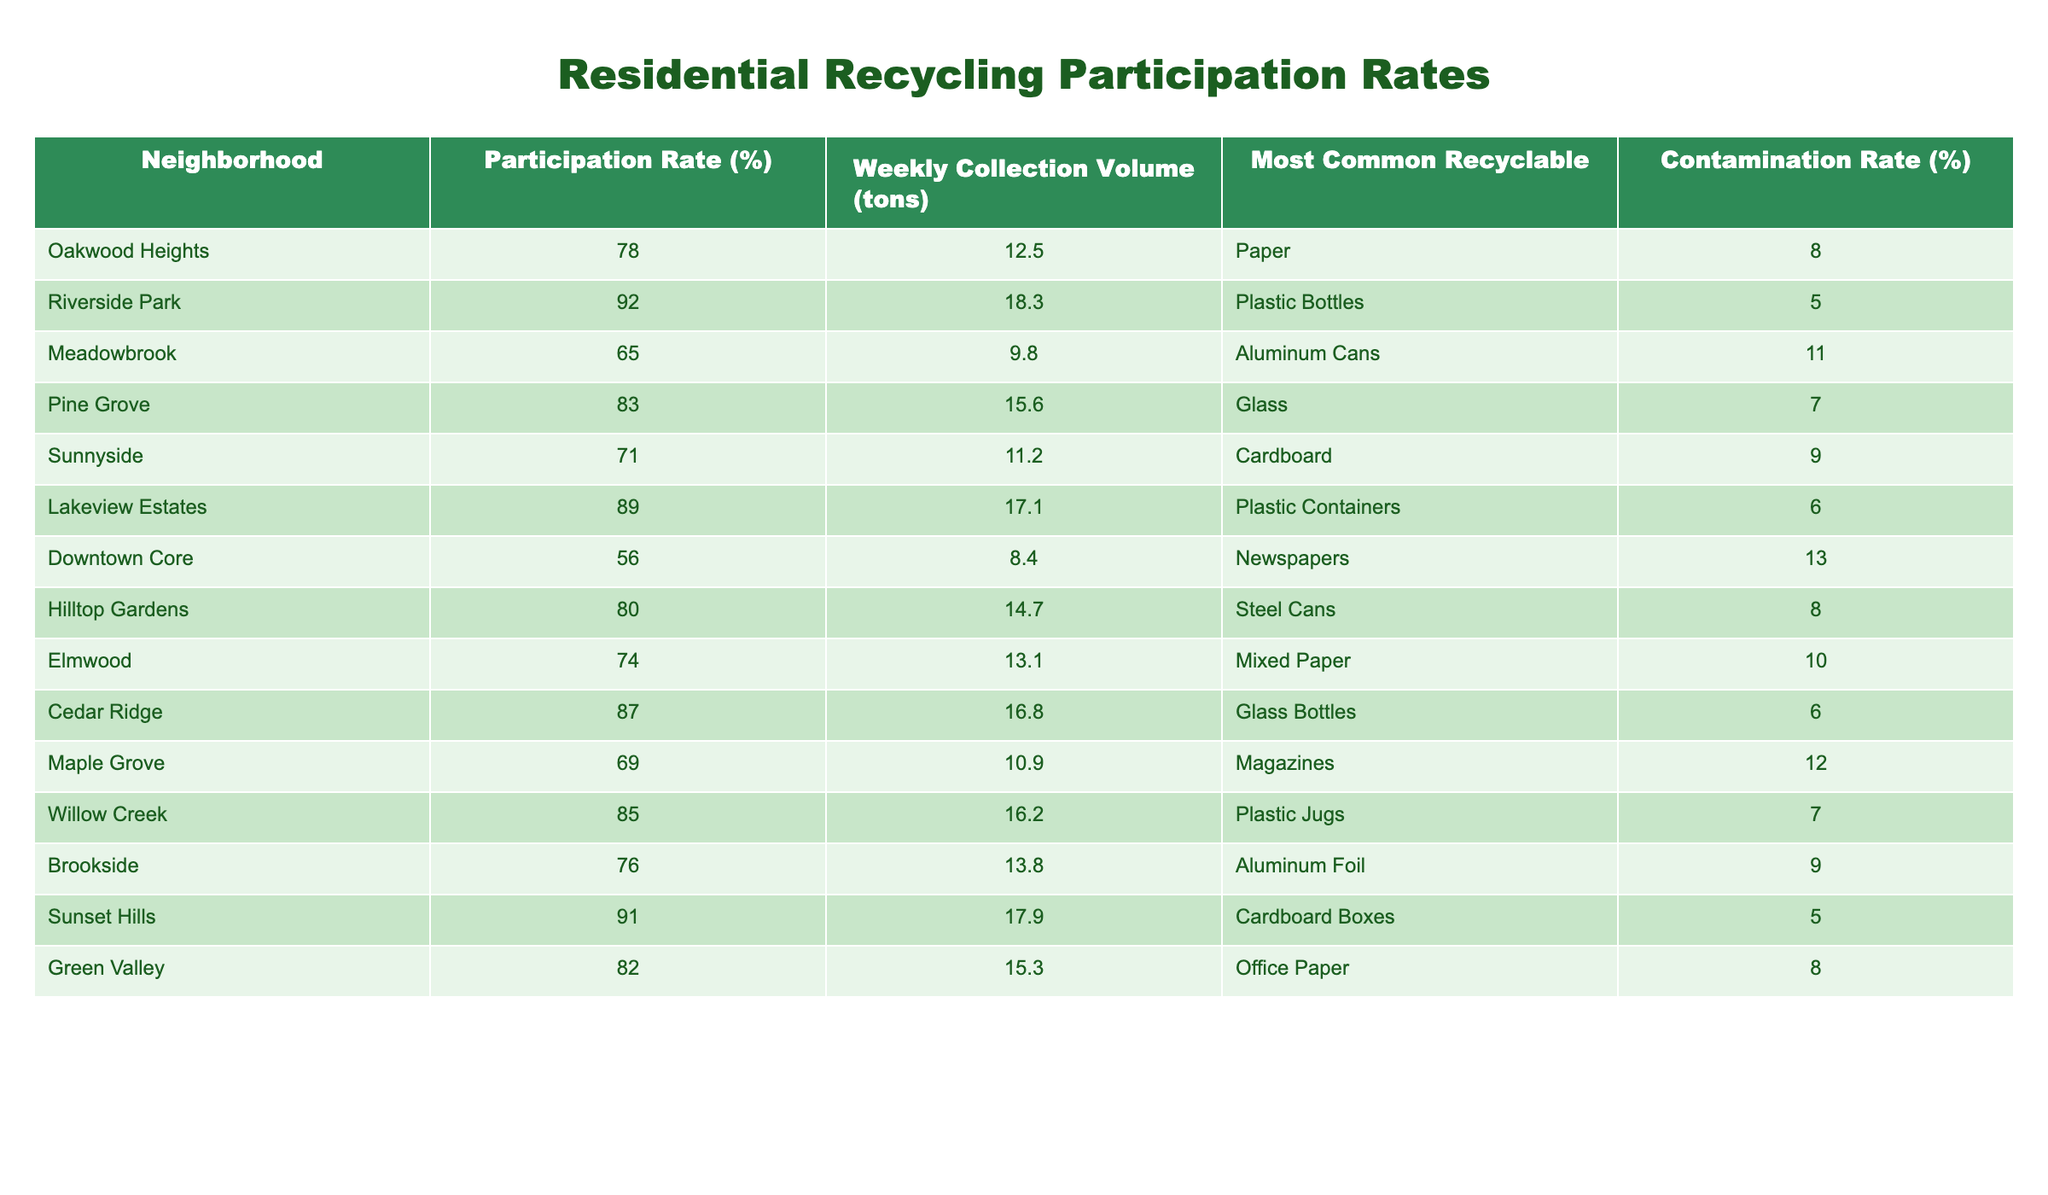What is the participation rate of Riverside Park? The table directly lists the participation rate for Riverside Park, which is provided under the "Participation Rate (%)" column.
Answer: 92% What is the most common recyclable item in Meadowbrook? By looking at the "Most Common Recyclable" column in the table for Meadowbrook, we can identify that the most common recyclable item is Aluminum Cans.
Answer: Aluminum Cans Which neighborhood has the highest contamination rate? To answer this, we check the "Contamination Rate (%)" column for all neighborhoods and compare the values. Downtown Core has the highest contamination rate of 13%.
Answer: Downtown Core What is the average participation rate across all neighborhoods? We sum all participation rates: (78 + 92 + 65 + 83 + 71 + 89 + 56 + 80 + 74 + 87 + 69 + 85 + 76 + 91 + 82) = 1266. There are 15 neighborhoods, so the average participation rate is 1266 / 15 = 84.4%.
Answer: 84.4% Is the participation rate in Willow Creek greater than the average participation rate? We already calculated the average participation rate as 84.4%. Willow Creek's participation rate is 85%, which is greater than the average.
Answer: Yes Which neighborhood has the highest weekly collection volume? We check the "Weekly Collection Volume (tons)" column and find that Sunset Hills has the highest collection volume at 17.9 tons.
Answer: Sunset Hills What is the difference in participation rates between Lakeview Estates and Downtown Core? Lakeview Estates has a participation rate of 89%, and Downtown Core has 56%. The difference is calculated as 89 - 56 = 33%.
Answer: 33% Does Cedar Ridge have a higher participation rate than Sunnyside? Comparing the participation rates, Cedar Ridge is at 87% and Sunnyside is at 71%. Since 87% is greater than 71%, Cedar Ridge has a higher participation rate.
Answer: Yes Which neighborhood has the most common recyclable item of Cardboard? Looking at the "Most Common Recyclable" column, we see that both Sunnyside and Sunset Hills list Cardboard as their most common recyclable item.
Answer: Sunnyside and Sunset Hills What is the total weekly collection volume for neighborhoods with a participation rate above 80%? We first identify the neighborhoods with participation rates above 80%: Riverside Park (18.3), Pine Grove (15.6), Lakeview Estates (17.1), Cedar Ridge (16.8), Willow Creek (16.2), Sunset Hills (17.9), and Green Valley (15.3). Now we sum these volumes: 18.3 + 15.6 + 17.1 + 16.8 + 16.2 + 17.9 + 15.3 = 117.2 tons.
Answer: 117.2 tons 